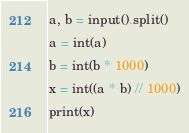<code> <loc_0><loc_0><loc_500><loc_500><_Python_>a, b = input().split()
a = int(a)
b = int(b * 1000)
x = int((a * b) // 1000)
print(x)</code> 